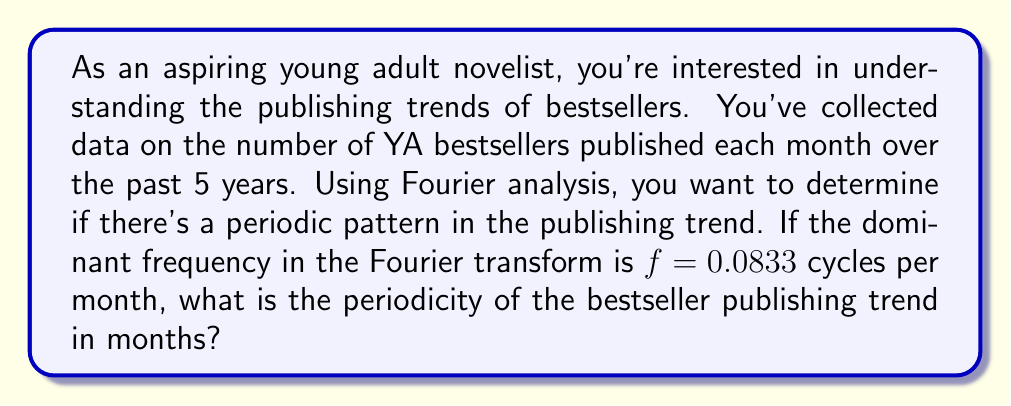Show me your answer to this math problem. To solve this problem, we need to understand the relationship between frequency and periodicity. In Fourier analysis, frequency represents how often a pattern repeats within a given time frame, while periodicity is the time it takes for one complete cycle of the pattern to occur.

The relationship between frequency ($f$) and period ($T$) is:

$$T = \frac{1}{f}$$

Where:
$T$ = period (in this case, in months)
$f$ = frequency (in cycles per month)

Given:
$f = 0.0833$ cycles per month

Let's substitute this into our equation:

$$T = \frac{1}{0.0833}$$

Now, let's calculate:

$$T = 12.0048 \approx 12$$

We round to the nearest whole number since we're dealing with months.

This result suggests that the bestseller publishing trend repeats approximately every 12 months, or once a year. This makes sense in the context of the publishing industry, as many books are released on an annual cycle, often coinciding with seasons or holidays.
Answer: The periodicity of the bestseller publishing trend is approximately 12 months. 